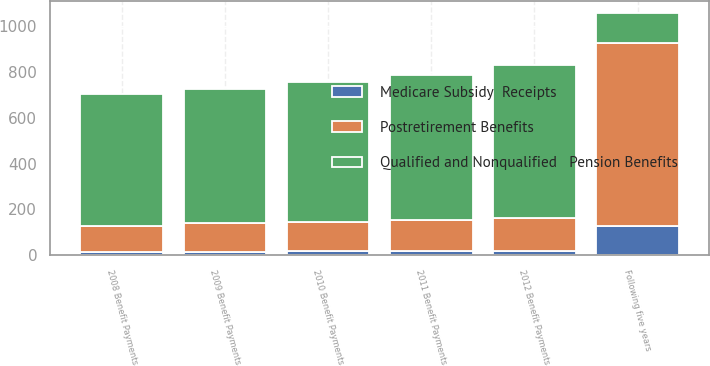<chart> <loc_0><loc_0><loc_500><loc_500><stacked_bar_chart><ecel><fcel>2008 Benefit Payments<fcel>2009 Benefit Payments<fcel>2010 Benefit Payments<fcel>2011 Benefit Payments<fcel>2012 Benefit Payments<fcel>Following five years<nl><fcel>Qualified and Nonqualified   Pension Benefits<fcel>574<fcel>588<fcel>607<fcel>628<fcel>665<fcel>130<nl><fcel>Postretirement Benefits<fcel>117<fcel>124<fcel>130<fcel>138<fcel>143<fcel>799<nl><fcel>Medicare Subsidy  Receipts<fcel>13<fcel>15<fcel>17<fcel>18<fcel>20<fcel>128<nl></chart> 